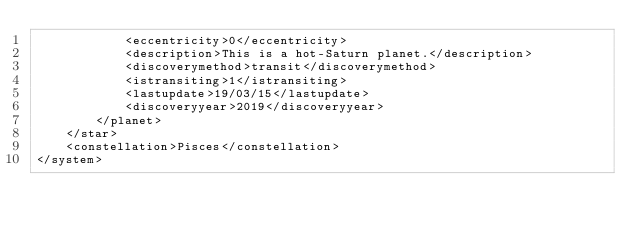Convert code to text. <code><loc_0><loc_0><loc_500><loc_500><_XML_>			<eccentricity>0</eccentricity>
			<description>This is a hot-Saturn planet.</description>
			<discoverymethod>transit</discoverymethod>
			<istransiting>1</istransiting>
			<lastupdate>19/03/15</lastupdate>
			<discoveryyear>2019</discoveryyear>
		</planet>
	</star>
	<constellation>Pisces</constellation>
</system>
</code> 